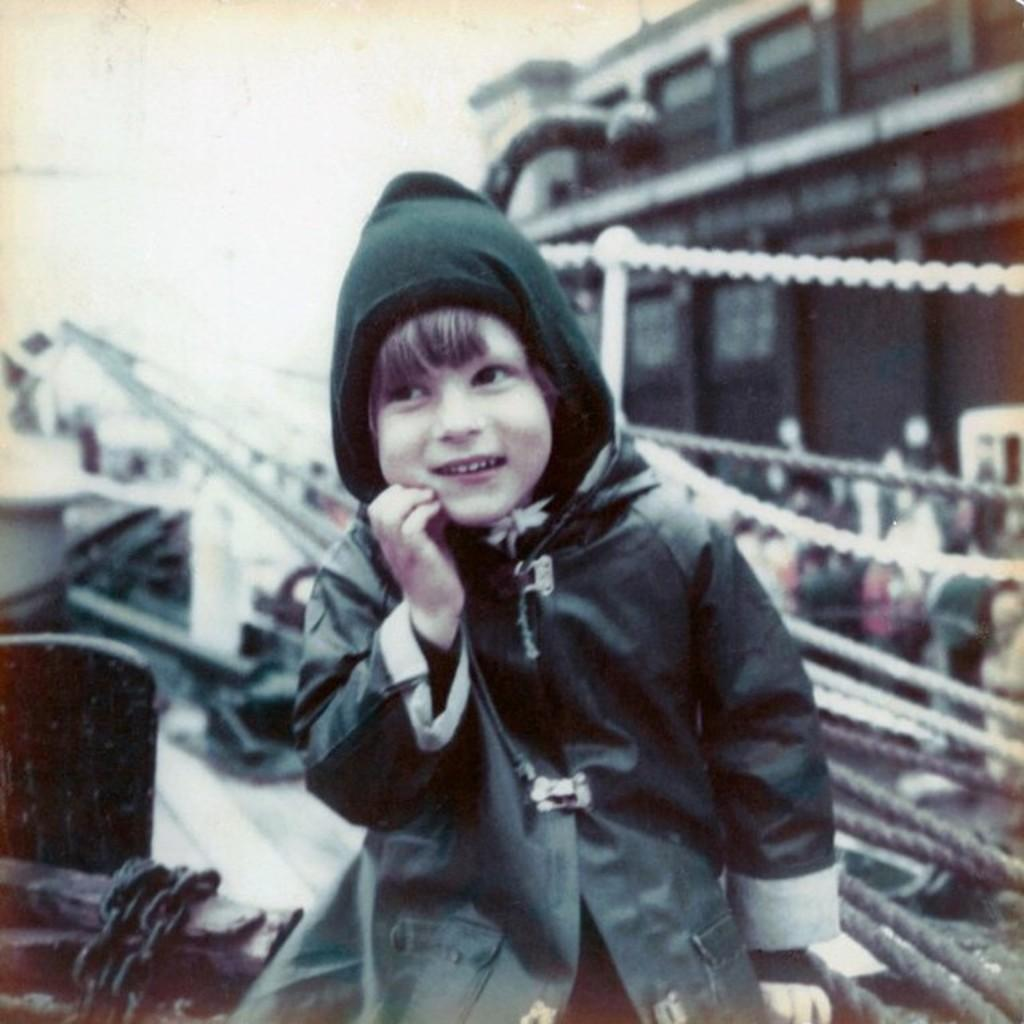What is the main subject of the image? The main subject of the image is a kid. What can be seen in the background of the image? There is a fence, a chain, buildings, and a crowd on the road in the image. What is visible in the sky in the image? The sky is visible in the image. Can you hear the whistle of the conductor in the image? There is no mention of a conductor or a whistle in the image, so it cannot be heard. Is there a cemetery visible in the image? There is no mention of a cemetery in the image, so it is not visible. 